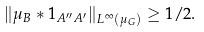Convert formula to latex. <formula><loc_0><loc_0><loc_500><loc_500>\| \mu _ { B } \ast 1 _ { A ^ { \prime \prime } A ^ { \prime } } \| _ { L ^ { \infty } ( \mu _ { G } ) } \geq 1 / 2 .</formula> 